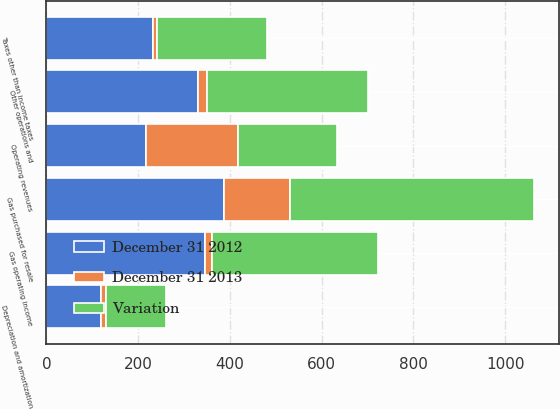Convert chart. <chart><loc_0><loc_0><loc_500><loc_500><stacked_bar_chart><ecel><fcel>Operating revenues<fcel>Gas purchased for resale<fcel>Other operations and<fcel>Depreciation and amortization<fcel>Taxes other than income taxes<fcel>Gas operating income<nl><fcel>Variation<fcel>216.5<fcel>532<fcel>351<fcel>130<fcel>241<fcel>362<nl><fcel>December 31 2012<fcel>216.5<fcel>387<fcel>330<fcel>120<fcel>232<fcel>346<nl><fcel>December 31 2013<fcel>201<fcel>145<fcel>21<fcel>10<fcel>9<fcel>16<nl></chart> 